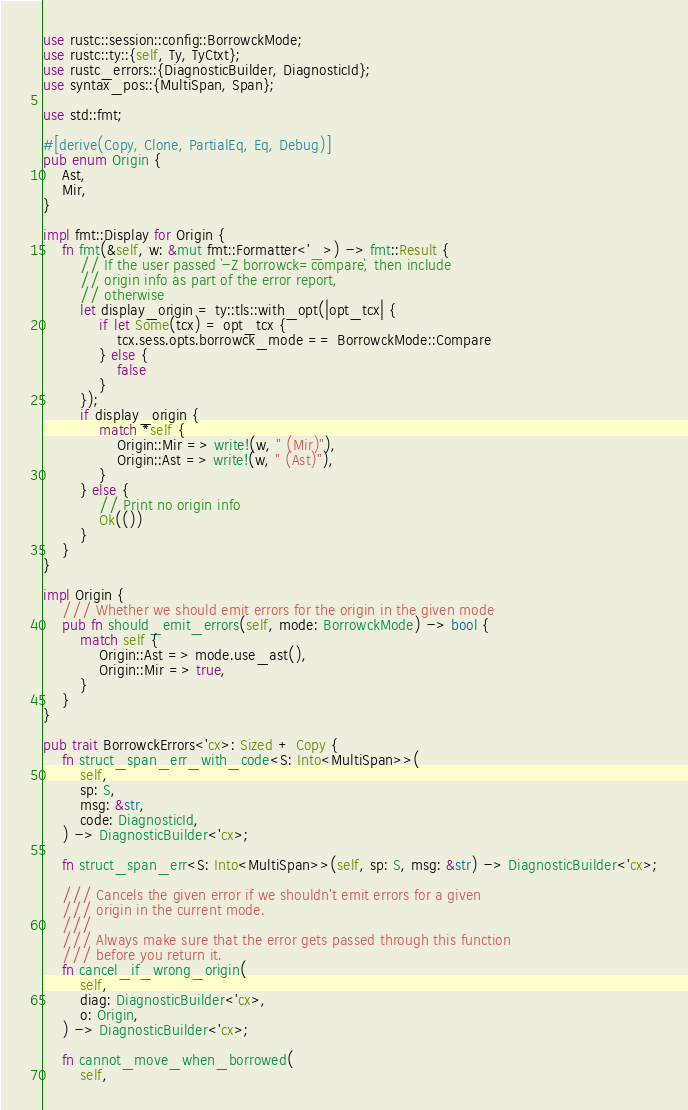Convert code to text. <code><loc_0><loc_0><loc_500><loc_500><_Rust_>use rustc::session::config::BorrowckMode;
use rustc::ty::{self, Ty, TyCtxt};
use rustc_errors::{DiagnosticBuilder, DiagnosticId};
use syntax_pos::{MultiSpan, Span};

use std::fmt;

#[derive(Copy, Clone, PartialEq, Eq, Debug)]
pub enum Origin {
    Ast,
    Mir,
}

impl fmt::Display for Origin {
    fn fmt(&self, w: &mut fmt::Formatter<'_>) -> fmt::Result {
        // If the user passed `-Z borrowck=compare`, then include
        // origin info as part of the error report,
        // otherwise
        let display_origin = ty::tls::with_opt(|opt_tcx| {
            if let Some(tcx) = opt_tcx {
                tcx.sess.opts.borrowck_mode == BorrowckMode::Compare
            } else {
                false
            }
        });
        if display_origin {
            match *self {
                Origin::Mir => write!(w, " (Mir)"),
                Origin::Ast => write!(w, " (Ast)"),
            }
        } else {
            // Print no origin info
            Ok(())
        }
    }
}

impl Origin {
    /// Whether we should emit errors for the origin in the given mode
    pub fn should_emit_errors(self, mode: BorrowckMode) -> bool {
        match self {
            Origin::Ast => mode.use_ast(),
            Origin::Mir => true,
        }
    }
}

pub trait BorrowckErrors<'cx>: Sized + Copy {
    fn struct_span_err_with_code<S: Into<MultiSpan>>(
        self,
        sp: S,
        msg: &str,
        code: DiagnosticId,
    ) -> DiagnosticBuilder<'cx>;

    fn struct_span_err<S: Into<MultiSpan>>(self, sp: S, msg: &str) -> DiagnosticBuilder<'cx>;

    /// Cancels the given error if we shouldn't emit errors for a given
    /// origin in the current mode.
    ///
    /// Always make sure that the error gets passed through this function
    /// before you return it.
    fn cancel_if_wrong_origin(
        self,
        diag: DiagnosticBuilder<'cx>,
        o: Origin,
    ) -> DiagnosticBuilder<'cx>;

    fn cannot_move_when_borrowed(
        self,</code> 